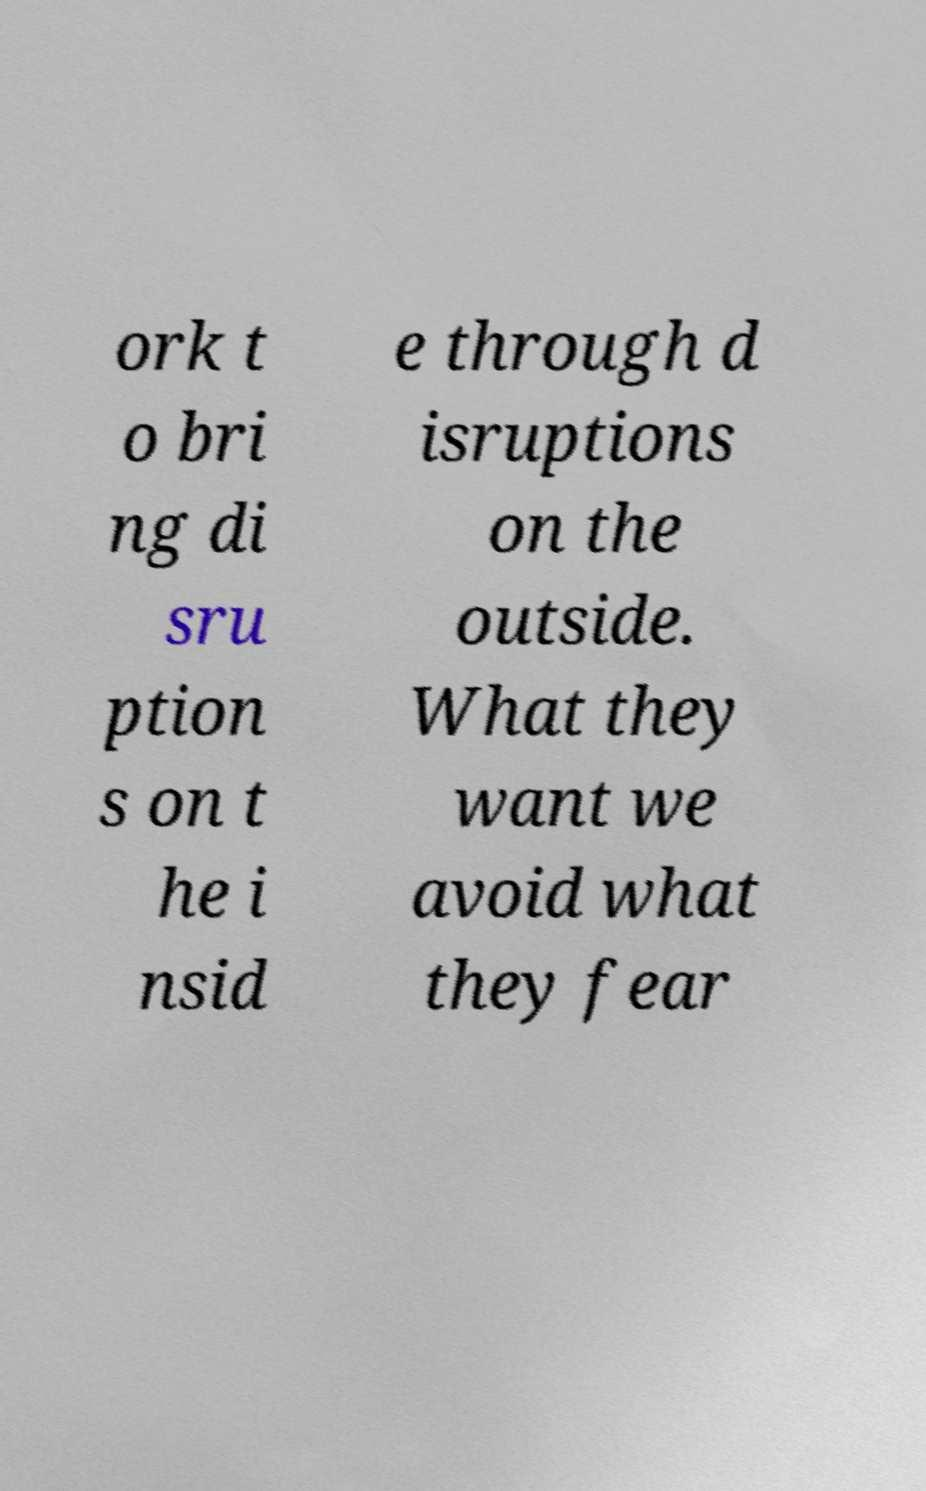For documentation purposes, I need the text within this image transcribed. Could you provide that? ork t o bri ng di sru ption s on t he i nsid e through d isruptions on the outside. What they want we avoid what they fear 